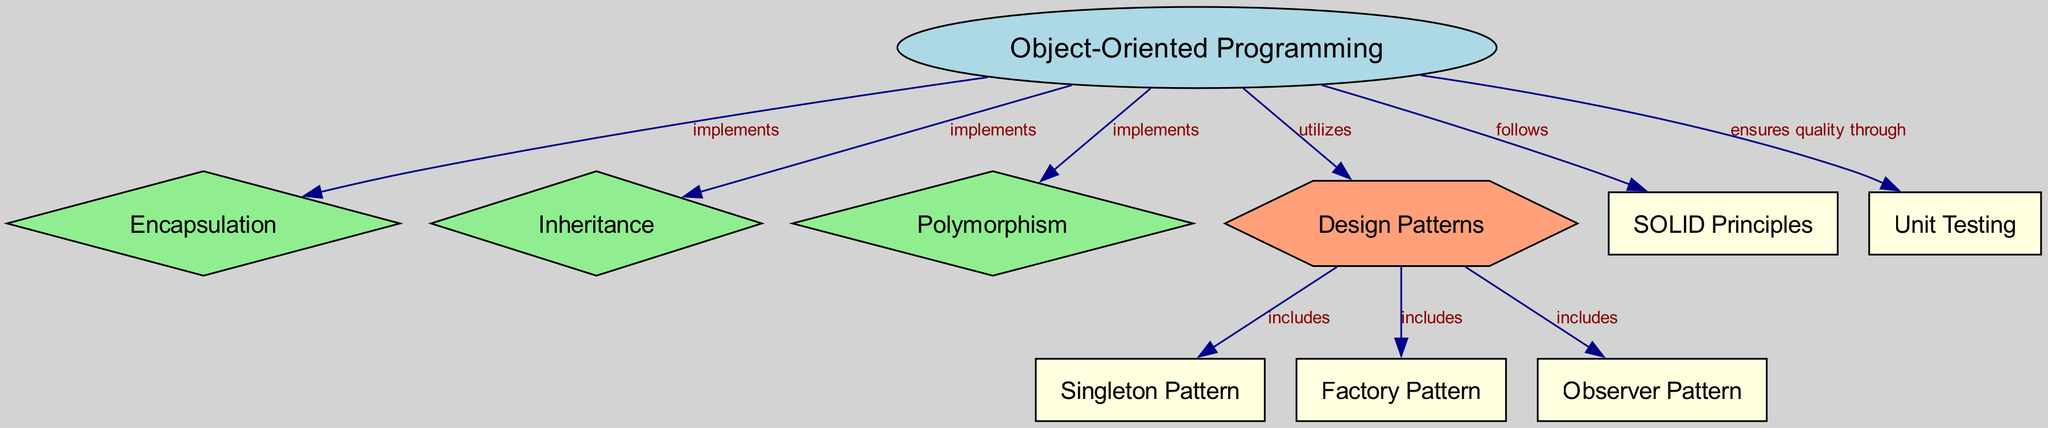What are the three main principles of Object-Oriented Programming? The diagram shows three nodes directly connected to the "Object-Oriented Programming" node, which are "Encapsulation," "Inheritance," and "Polymorphism."
Answer: Encapsulation, Inheritance, Polymorphism How many design patterns are included in the "Design Patterns" node? The "Design Patterns" node includes three edges directed towards "Singleton," "Factory," and "Observer," indicating these patterns are part of the design patterns.
Answer: 3 Which principle does Object-Oriented Programming follow according to the diagram? The diagram indicates a direct edge from "Object-Oriented Programming" to "SOLID Principles," showing that OOP follows this principle.
Answer: SOLID Principles What is the relationship between "Unit Testing" and "Object-Oriented Programming"? There is a directed edge labeled "ensures quality through" from the "Object-Oriented Programming" node to the "Unit Testing" node, illustrating that unit testing is a method associated with OOP.
Answer: ensures quality through Name one design pattern that is part of the "Design Patterns." The "Design Patterns" node connects to "Singleton," "Factory," and "Observer," any of which can be the answer. The prompt specifies to name one.
Answer: Singleton How does object-oriented programming utilize design patterns? There is an edge between "Object-Oriented Programming" and "Design Patterns" labeled "utilizes," indicating that OOP makes use of these patterns in its architecture.
Answer: utilizes Which node represents the concept that aggregates the main features of OOP? The "Object-Oriented Programming" node is the central node connected to the three main principles and design patterns, serving as the overarching concept.
Answer: Object-Oriented Programming What type of node is the "Design Patterns"? In the diagram, "Design Patterns" is represented as a hexagon, visually distinguishing it from other node shapes, which helps identify its role within the broader context of OOP.
Answer: hexagon Which of the following is not one of the main principles of OOP depicted in the diagram: Encapsulation, Composition, or Inheritance? "Composition" does not appear as a node connected to "Object-Oriented Programming," whereas both "Encapsulation" and "Inheritance" do, indicating that "Composition" is not among the main principles shown.
Answer: Composition 